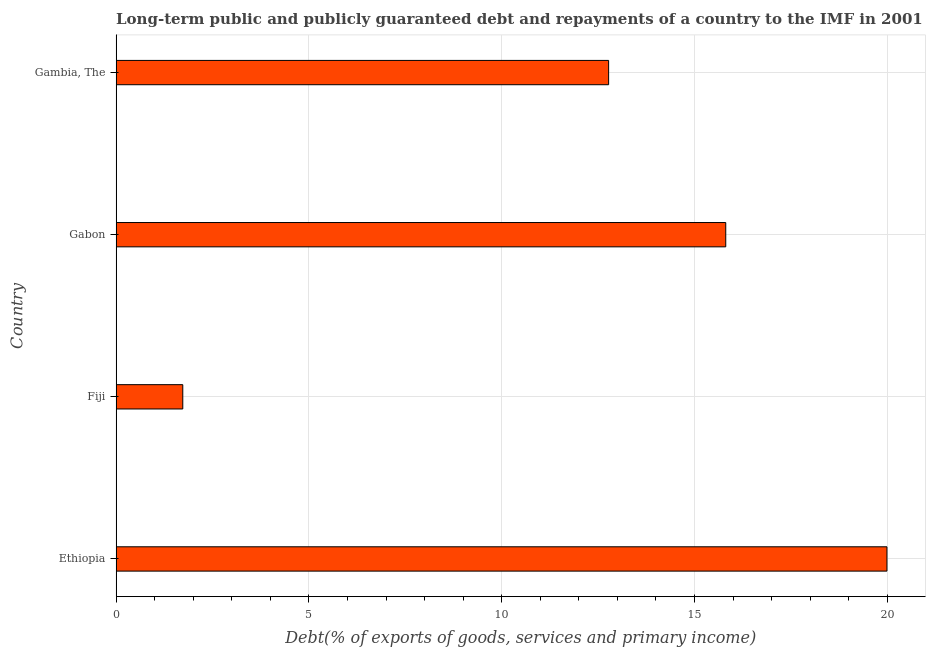Does the graph contain grids?
Offer a terse response. Yes. What is the title of the graph?
Provide a succinct answer. Long-term public and publicly guaranteed debt and repayments of a country to the IMF in 2001. What is the label or title of the X-axis?
Offer a terse response. Debt(% of exports of goods, services and primary income). What is the label or title of the Y-axis?
Make the answer very short. Country. What is the debt service in Gabon?
Your response must be concise. 15.81. Across all countries, what is the maximum debt service?
Provide a short and direct response. 19.99. Across all countries, what is the minimum debt service?
Provide a short and direct response. 1.73. In which country was the debt service maximum?
Make the answer very short. Ethiopia. In which country was the debt service minimum?
Your answer should be very brief. Fiji. What is the sum of the debt service?
Your answer should be very brief. 50.3. What is the difference between the debt service in Fiji and Gabon?
Provide a succinct answer. -14.08. What is the average debt service per country?
Provide a short and direct response. 12.57. What is the median debt service?
Your answer should be compact. 14.29. What is the ratio of the debt service in Fiji to that in Gambia, The?
Offer a terse response. 0.14. What is the difference between the highest and the second highest debt service?
Give a very brief answer. 4.18. What is the difference between the highest and the lowest debt service?
Your answer should be very brief. 18.26. In how many countries, is the debt service greater than the average debt service taken over all countries?
Keep it short and to the point. 3. What is the difference between two consecutive major ticks on the X-axis?
Make the answer very short. 5. What is the Debt(% of exports of goods, services and primary income) in Ethiopia?
Give a very brief answer. 19.99. What is the Debt(% of exports of goods, services and primary income) of Fiji?
Make the answer very short. 1.73. What is the Debt(% of exports of goods, services and primary income) of Gabon?
Keep it short and to the point. 15.81. What is the Debt(% of exports of goods, services and primary income) in Gambia, The?
Provide a succinct answer. 12.77. What is the difference between the Debt(% of exports of goods, services and primary income) in Ethiopia and Fiji?
Provide a short and direct response. 18.26. What is the difference between the Debt(% of exports of goods, services and primary income) in Ethiopia and Gabon?
Provide a succinct answer. 4.18. What is the difference between the Debt(% of exports of goods, services and primary income) in Ethiopia and Gambia, The?
Provide a succinct answer. 7.22. What is the difference between the Debt(% of exports of goods, services and primary income) in Fiji and Gabon?
Keep it short and to the point. -14.08. What is the difference between the Debt(% of exports of goods, services and primary income) in Fiji and Gambia, The?
Make the answer very short. -11.04. What is the difference between the Debt(% of exports of goods, services and primary income) in Gabon and Gambia, The?
Provide a short and direct response. 3.04. What is the ratio of the Debt(% of exports of goods, services and primary income) in Ethiopia to that in Fiji?
Your answer should be compact. 11.56. What is the ratio of the Debt(% of exports of goods, services and primary income) in Ethiopia to that in Gabon?
Make the answer very short. 1.26. What is the ratio of the Debt(% of exports of goods, services and primary income) in Ethiopia to that in Gambia, The?
Provide a succinct answer. 1.56. What is the ratio of the Debt(% of exports of goods, services and primary income) in Fiji to that in Gabon?
Offer a terse response. 0.11. What is the ratio of the Debt(% of exports of goods, services and primary income) in Fiji to that in Gambia, The?
Provide a short and direct response. 0.14. What is the ratio of the Debt(% of exports of goods, services and primary income) in Gabon to that in Gambia, The?
Give a very brief answer. 1.24. 